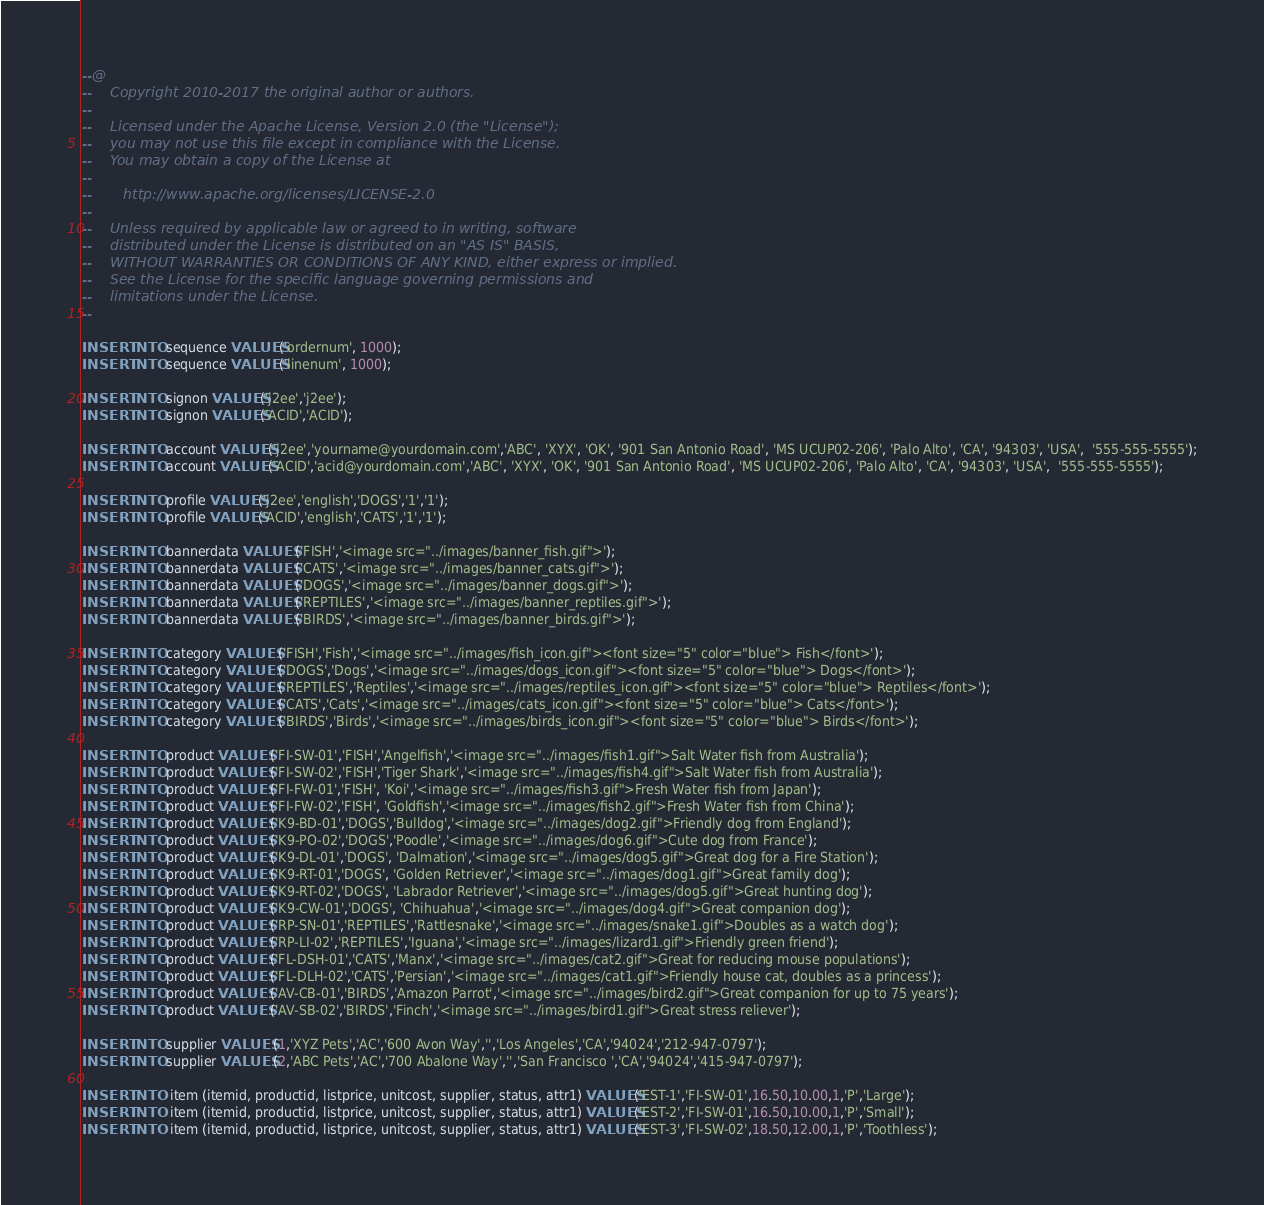<code> <loc_0><loc_0><loc_500><loc_500><_SQL_>--@
--    Copyright 2010-2017 the original author or authors.
--
--    Licensed under the Apache License, Version 2.0 (the "License");
--    you may not use this file except in compliance with the License.
--    You may obtain a copy of the License at
--
--       http://www.apache.org/licenses/LICENSE-2.0
--
--    Unless required by applicable law or agreed to in writing, software
--    distributed under the License is distributed on an "AS IS" BASIS,
--    WITHOUT WARRANTIES OR CONDITIONS OF ANY KIND, either express or implied.
--    See the License for the specific language governing permissions and
--    limitations under the License.
--

INSERT INTO sequence VALUES('ordernum', 1000);
INSERT INTO sequence VALUES('linenum', 1000);

INSERT INTO signon VALUES('j2ee','j2ee');
INSERT INTO signon VALUES('ACID','ACID');

INSERT INTO account VALUES('j2ee','yourname@yourdomain.com','ABC', 'XYX', 'OK', '901 San Antonio Road', 'MS UCUP02-206', 'Palo Alto', 'CA', '94303', 'USA',  '555-555-5555');
INSERT INTO account VALUES('ACID','acid@yourdomain.com','ABC', 'XYX', 'OK', '901 San Antonio Road', 'MS UCUP02-206', 'Palo Alto', 'CA', '94303', 'USA',  '555-555-5555');

INSERT INTO profile VALUES('j2ee','english','DOGS','1','1');
INSERT INTO profile VALUES('ACID','english','CATS','1','1');

INSERT INTO bannerdata VALUES ('FISH','<image src="../images/banner_fish.gif">');
INSERT INTO bannerdata VALUES ('CATS','<image src="../images/banner_cats.gif">');
INSERT INTO bannerdata VALUES ('DOGS','<image src="../images/banner_dogs.gif">');
INSERT INTO bannerdata VALUES ('REPTILES','<image src="../images/banner_reptiles.gif">');
INSERT INTO bannerdata VALUES ('BIRDS','<image src="../images/banner_birds.gif">');

INSERT INTO category VALUES ('FISH','Fish','<image src="../images/fish_icon.gif"><font size="5" color="blue"> Fish</font>');
INSERT INTO category VALUES ('DOGS','Dogs','<image src="../images/dogs_icon.gif"><font size="5" color="blue"> Dogs</font>');
INSERT INTO category VALUES ('REPTILES','Reptiles','<image src="../images/reptiles_icon.gif"><font size="5" color="blue"> Reptiles</font>');
INSERT INTO category VALUES ('CATS','Cats','<image src="../images/cats_icon.gif"><font size="5" color="blue"> Cats</font>');
INSERT INTO category VALUES ('BIRDS','Birds','<image src="../images/birds_icon.gif"><font size="5" color="blue"> Birds</font>');

INSERT INTO product VALUES ('FI-SW-01','FISH','Angelfish','<image src="../images/fish1.gif">Salt Water fish from Australia');
INSERT INTO product VALUES ('FI-SW-02','FISH','Tiger Shark','<image src="../images/fish4.gif">Salt Water fish from Australia');
INSERT INTO product VALUES ('FI-FW-01','FISH', 'Koi','<image src="../images/fish3.gif">Fresh Water fish from Japan');
INSERT INTO product VALUES ('FI-FW-02','FISH', 'Goldfish','<image src="../images/fish2.gif">Fresh Water fish from China');
INSERT INTO product VALUES ('K9-BD-01','DOGS','Bulldog','<image src="../images/dog2.gif">Friendly dog from England');
INSERT INTO product VALUES ('K9-PO-02','DOGS','Poodle','<image src="../images/dog6.gif">Cute dog from France');
INSERT INTO product VALUES ('K9-DL-01','DOGS', 'Dalmation','<image src="../images/dog5.gif">Great dog for a Fire Station');
INSERT INTO product VALUES ('K9-RT-01','DOGS', 'Golden Retriever','<image src="../images/dog1.gif">Great family dog');
INSERT INTO product VALUES ('K9-RT-02','DOGS', 'Labrador Retriever','<image src="../images/dog5.gif">Great hunting dog');
INSERT INTO product VALUES ('K9-CW-01','DOGS', 'Chihuahua','<image src="../images/dog4.gif">Great companion dog');
INSERT INTO product VALUES ('RP-SN-01','REPTILES','Rattlesnake','<image src="../images/snake1.gif">Doubles as a watch dog');
INSERT INTO product VALUES ('RP-LI-02','REPTILES','Iguana','<image src="../images/lizard1.gif">Friendly green friend');
INSERT INTO product VALUES ('FL-DSH-01','CATS','Manx','<image src="../images/cat2.gif">Great for reducing mouse populations');
INSERT INTO product VALUES ('FL-DLH-02','CATS','Persian','<image src="../images/cat1.gif">Friendly house cat, doubles as a princess');
INSERT INTO product VALUES ('AV-CB-01','BIRDS','Amazon Parrot','<image src="../images/bird2.gif">Great companion for up to 75 years');
INSERT INTO product VALUES ('AV-SB-02','BIRDS','Finch','<image src="../images/bird1.gif">Great stress reliever');

INSERT INTO supplier VALUES (1,'XYZ Pets','AC','600 Avon Way','','Los Angeles','CA','94024','212-947-0797');
INSERT INTO supplier VALUES (2,'ABC Pets','AC','700 Abalone Way','','San Francisco ','CA','94024','415-947-0797');

INSERT INTO  item (itemid, productid, listprice, unitcost, supplier, status, attr1) VALUES('EST-1','FI-SW-01',16.50,10.00,1,'P','Large');
INSERT INTO  item (itemid, productid, listprice, unitcost, supplier, status, attr1) VALUES('EST-2','FI-SW-01',16.50,10.00,1,'P','Small');
INSERT INTO  item (itemid, productid, listprice, unitcost, supplier, status, attr1) VALUES('EST-3','FI-SW-02',18.50,12.00,1,'P','Toothless');</code> 